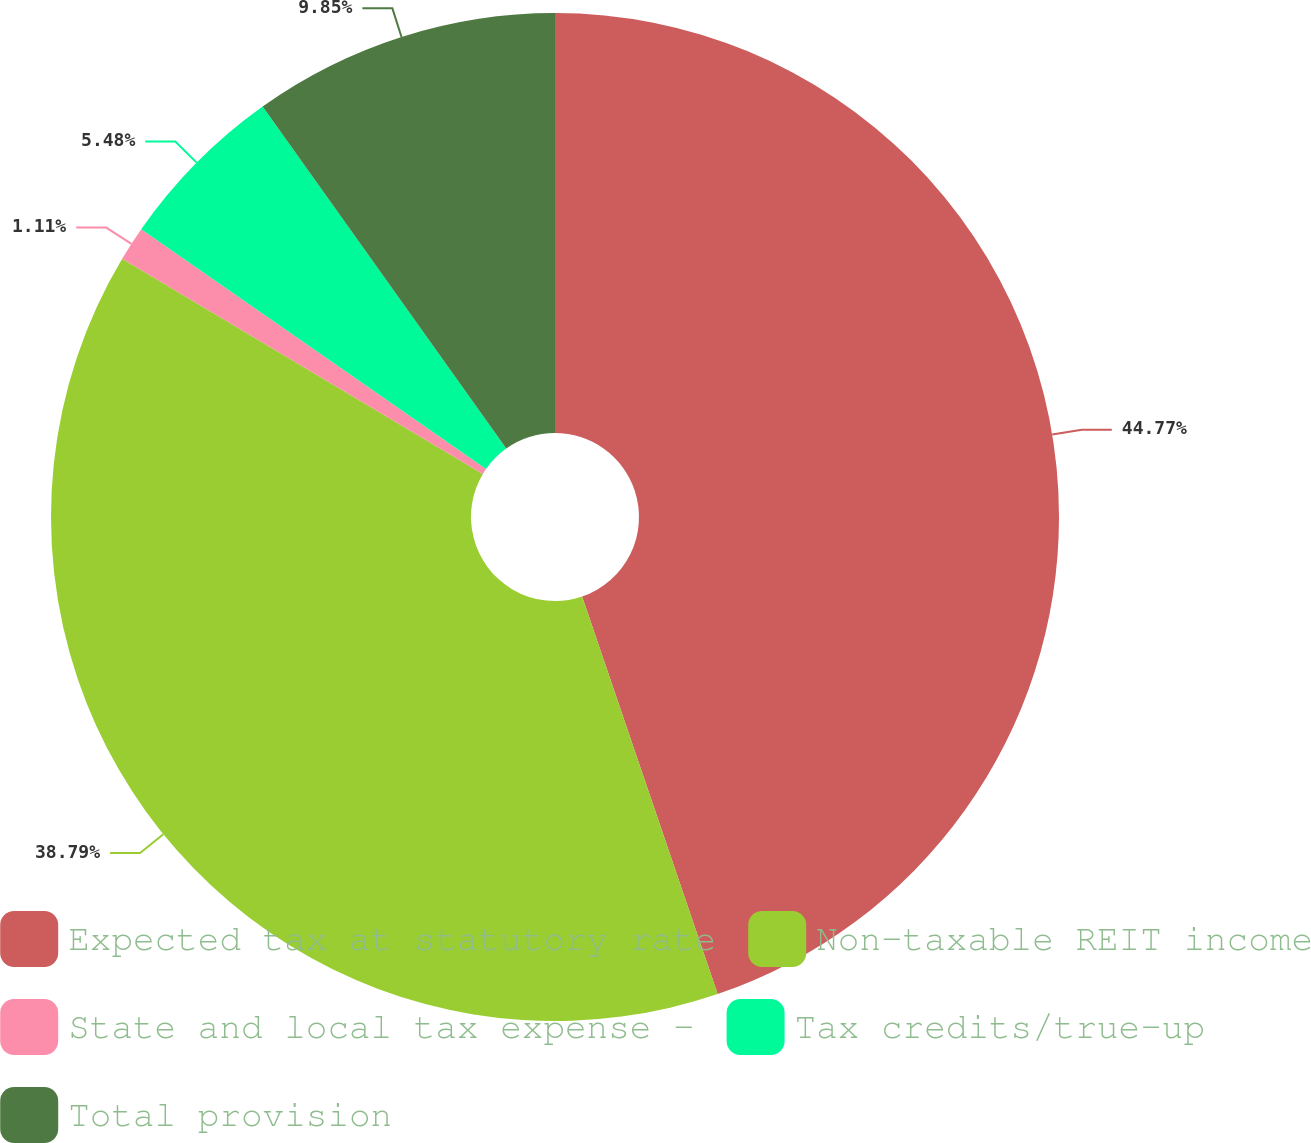Convert chart to OTSL. <chart><loc_0><loc_0><loc_500><loc_500><pie_chart><fcel>Expected tax at statutory rate<fcel>Non-taxable REIT income<fcel>State and local tax expense -<fcel>Tax credits/true-up<fcel>Total provision<nl><fcel>44.77%<fcel>38.79%<fcel>1.11%<fcel>5.48%<fcel>9.85%<nl></chart> 